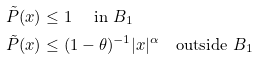<formula> <loc_0><loc_0><loc_500><loc_500>\tilde { P } ( x ) & \leq 1 \quad \text { in } B _ { 1 } \\ \tilde { P } ( x ) & \leq ( 1 - \theta ) ^ { - 1 } | x | ^ { \alpha } \quad \text {outside } B _ { 1 }</formula> 